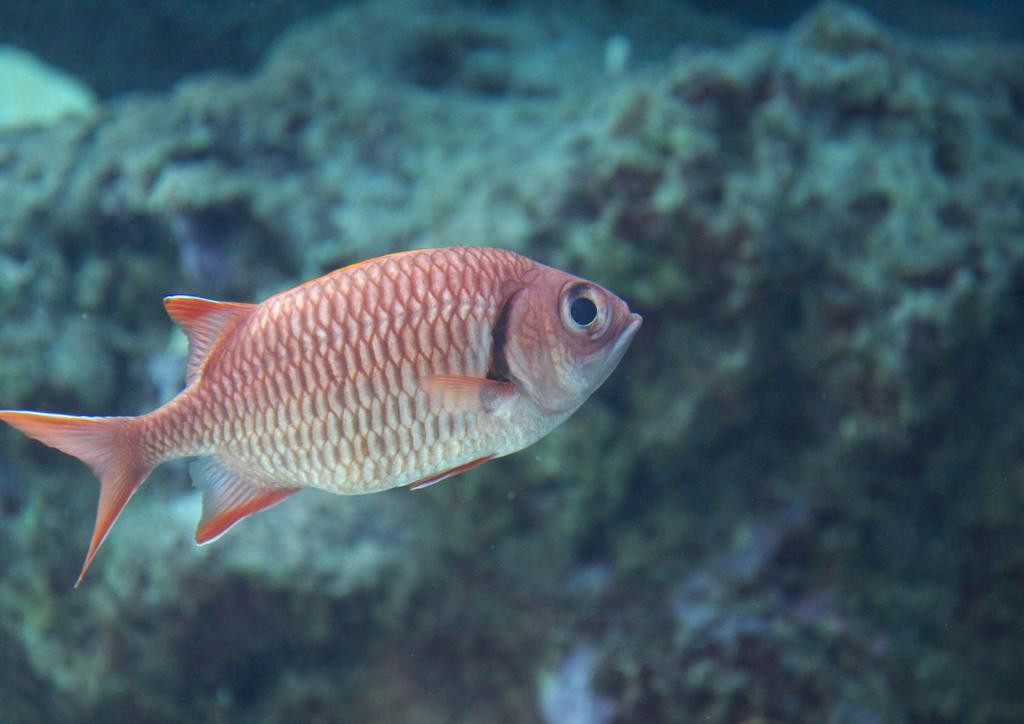What type of animal can be seen in the water in the image? There is a fish in the water in the image. What type of fire can be seen burning in the water in the image? There is no fire present in the image; it features a fish in the water. 